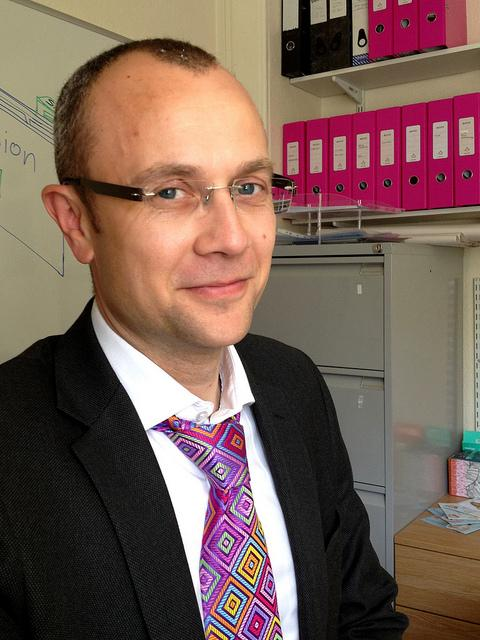What are the pink objects on the shelf? binders 